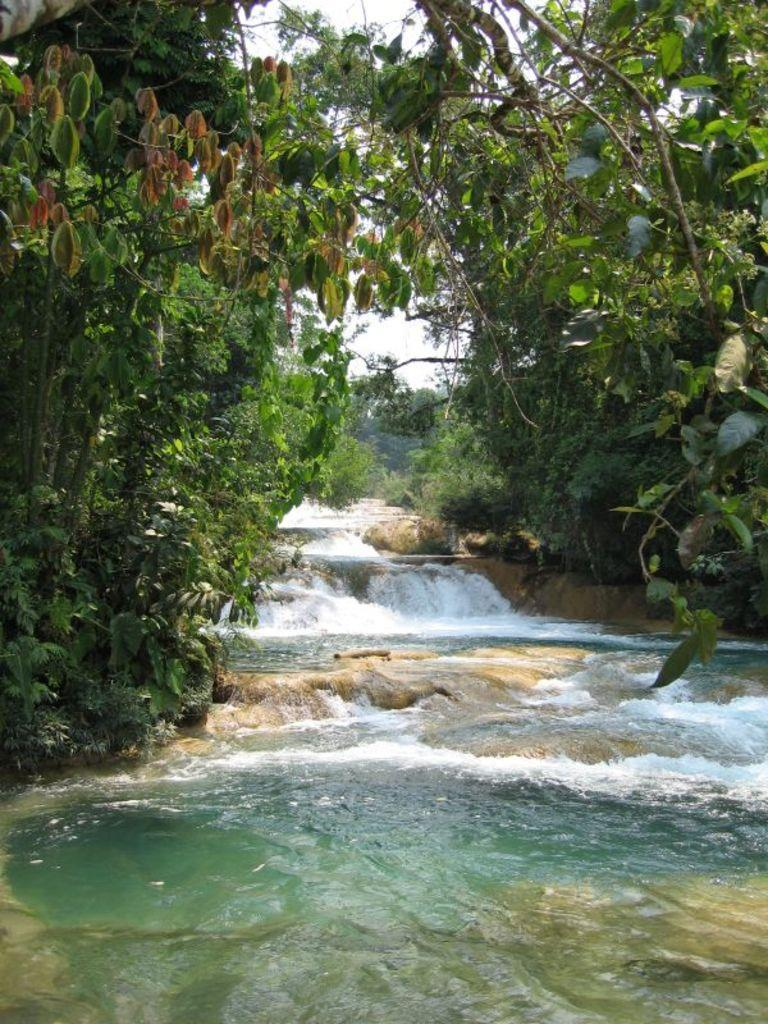What is located in the middle of the image? There is water in the middle of the image. What type of vegetation is on either side of the image? There are trees on either side of the image. What is visible in the background of the image? The sky is visible in the background of the image. How many ants can be seen climbing the knot in the bed in the image? There is no bed, knot, or ants present in the image. 